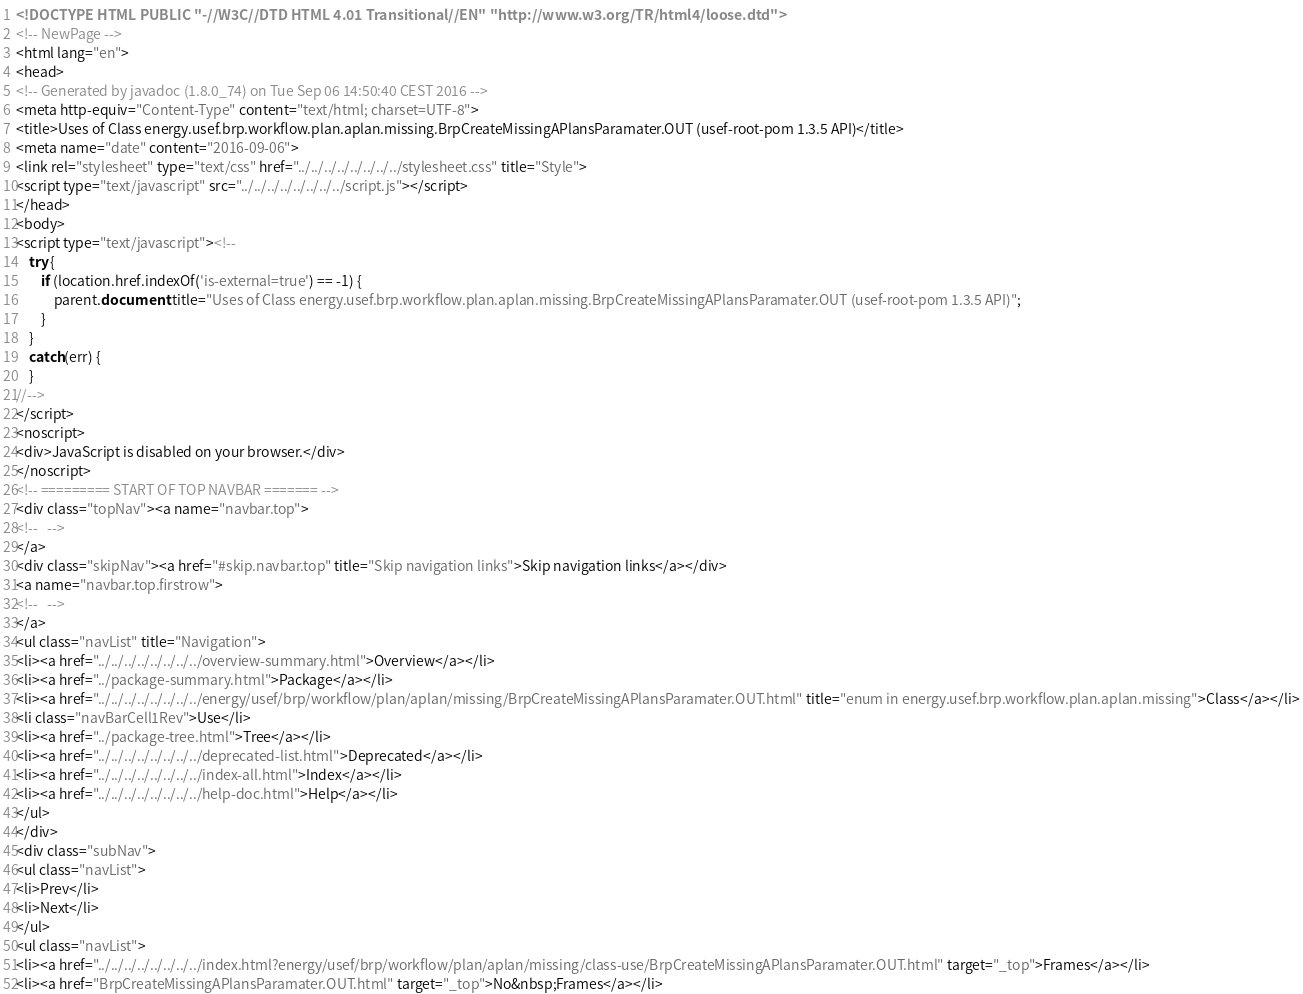Convert code to text. <code><loc_0><loc_0><loc_500><loc_500><_HTML_><!DOCTYPE HTML PUBLIC "-//W3C//DTD HTML 4.01 Transitional//EN" "http://www.w3.org/TR/html4/loose.dtd">
<!-- NewPage -->
<html lang="en">
<head>
<!-- Generated by javadoc (1.8.0_74) on Tue Sep 06 14:50:40 CEST 2016 -->
<meta http-equiv="Content-Type" content="text/html; charset=UTF-8">
<title>Uses of Class energy.usef.brp.workflow.plan.aplan.missing.BrpCreateMissingAPlansParamater.OUT (usef-root-pom 1.3.5 API)</title>
<meta name="date" content="2016-09-06">
<link rel="stylesheet" type="text/css" href="../../../../../../../../stylesheet.css" title="Style">
<script type="text/javascript" src="../../../../../../../../script.js"></script>
</head>
<body>
<script type="text/javascript"><!--
    try {
        if (location.href.indexOf('is-external=true') == -1) {
            parent.document.title="Uses of Class energy.usef.brp.workflow.plan.aplan.missing.BrpCreateMissingAPlansParamater.OUT (usef-root-pom 1.3.5 API)";
        }
    }
    catch(err) {
    }
//-->
</script>
<noscript>
<div>JavaScript is disabled on your browser.</div>
</noscript>
<!-- ========= START OF TOP NAVBAR ======= -->
<div class="topNav"><a name="navbar.top">
<!--   -->
</a>
<div class="skipNav"><a href="#skip.navbar.top" title="Skip navigation links">Skip navigation links</a></div>
<a name="navbar.top.firstrow">
<!--   -->
</a>
<ul class="navList" title="Navigation">
<li><a href="../../../../../../../../overview-summary.html">Overview</a></li>
<li><a href="../package-summary.html">Package</a></li>
<li><a href="../../../../../../../../energy/usef/brp/workflow/plan/aplan/missing/BrpCreateMissingAPlansParamater.OUT.html" title="enum in energy.usef.brp.workflow.plan.aplan.missing">Class</a></li>
<li class="navBarCell1Rev">Use</li>
<li><a href="../package-tree.html">Tree</a></li>
<li><a href="../../../../../../../../deprecated-list.html">Deprecated</a></li>
<li><a href="../../../../../../../../index-all.html">Index</a></li>
<li><a href="../../../../../../../../help-doc.html">Help</a></li>
</ul>
</div>
<div class="subNav">
<ul class="navList">
<li>Prev</li>
<li>Next</li>
</ul>
<ul class="navList">
<li><a href="../../../../../../../../index.html?energy/usef/brp/workflow/plan/aplan/missing/class-use/BrpCreateMissingAPlansParamater.OUT.html" target="_top">Frames</a></li>
<li><a href="BrpCreateMissingAPlansParamater.OUT.html" target="_top">No&nbsp;Frames</a></li></code> 